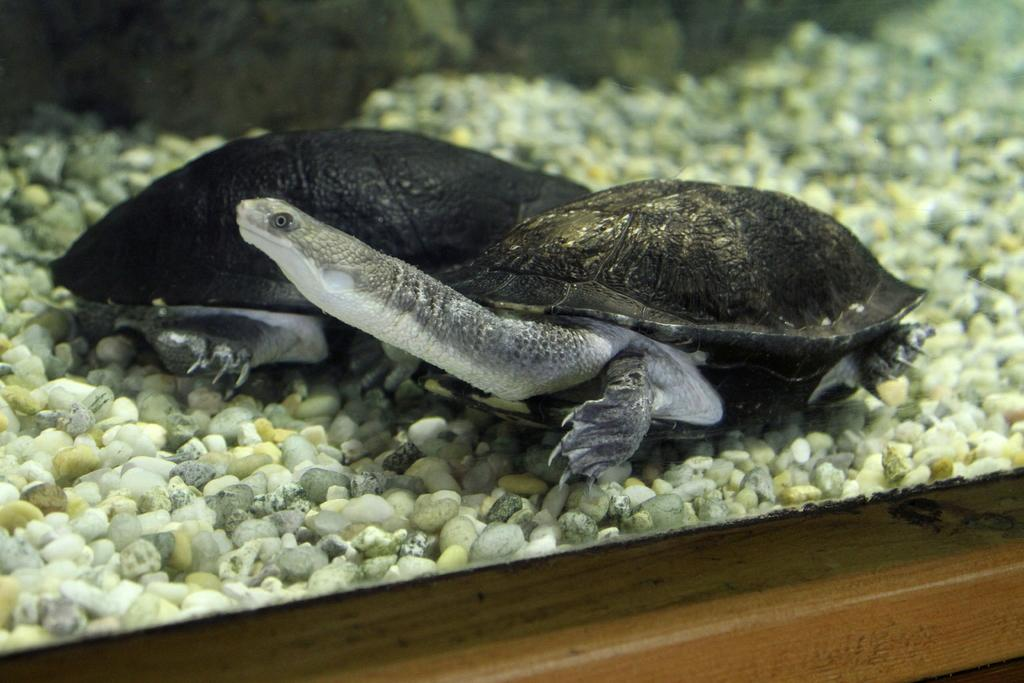What is the main object in the image? There is an aquarium in the image. What is inside the aquarium? The aquarium contains water and stones. Are there any living creatures in the aquarium? Yes, there are two turtles in the aquarium. On what surface is the aquarium placed? The aquarium is placed on a wooden table. Can you see a bee flying around the turtles in the aquarium? No, there are no bees present in the image. The image only shows an aquarium with water, stones, and two turtles, and it is placed on a wooden table. 